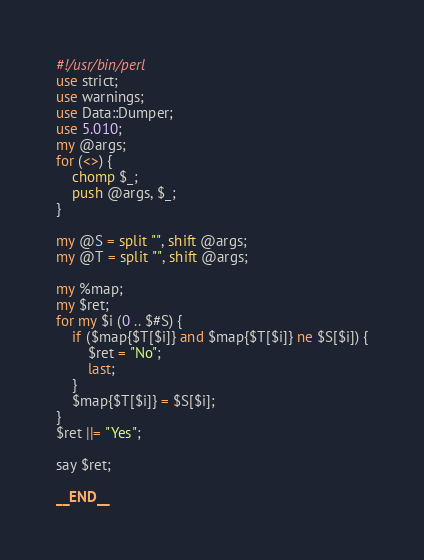Convert code to text. <code><loc_0><loc_0><loc_500><loc_500><_Perl_>#!/usr/bin/perl
use strict;
use warnings;
use Data::Dumper;
use 5.010;
my @args;
for (<>) {
    chomp $_;
    push @args, $_;
}

my @S = split "", shift @args;
my @T = split "", shift @args;

my %map;
my $ret;
for my $i (0 .. $#S) {
    if ($map{$T[$i]} and $map{$T[$i]} ne $S[$i]) {
        $ret = "No";
        last;
    }
    $map{$T[$i]} = $S[$i];
}
$ret ||= "Yes";

say $ret;

__END__

</code> 